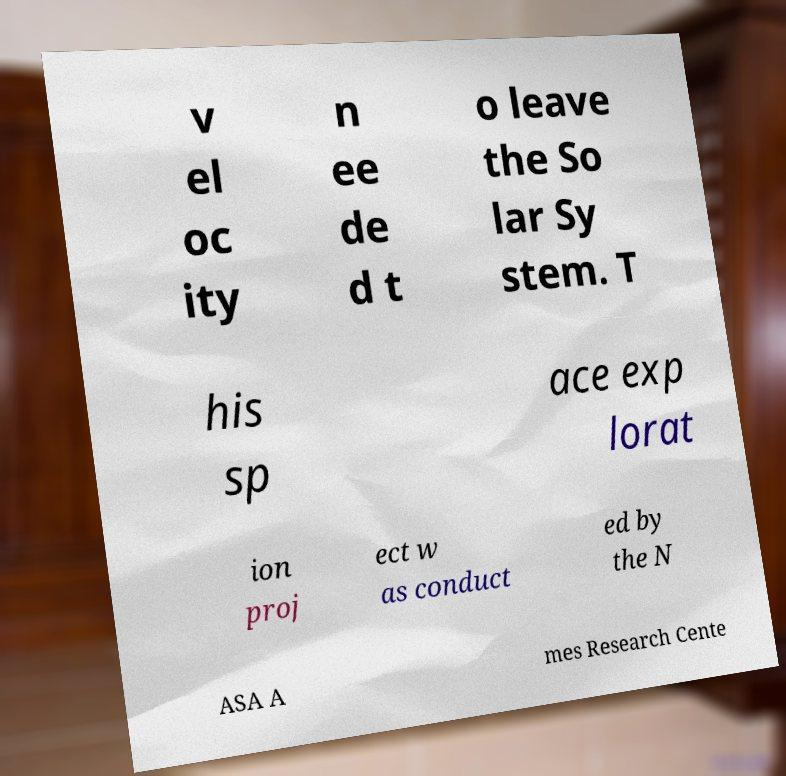Could you extract and type out the text from this image? v el oc ity n ee de d t o leave the So lar Sy stem. T his sp ace exp lorat ion proj ect w as conduct ed by the N ASA A mes Research Cente 